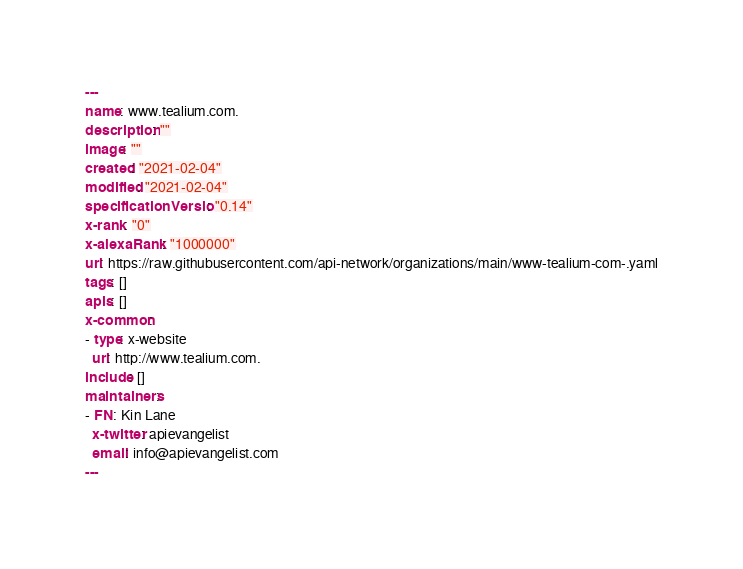Convert code to text. <code><loc_0><loc_0><loc_500><loc_500><_YAML_>---
name: www.tealium.com.
description: ""
image: ""
created: "2021-02-04"
modified: "2021-02-04"
specificationVersion: "0.14"
x-rank: "0"
x-alexaRank: "1000000"
url: https://raw.githubusercontent.com/api-network/organizations/main/www-tealium-com-.yaml
tags: []
apis: []
x-common:
- type: x-website
  url: http://www.tealium.com.
include: []
maintainers:
- FN: Kin Lane
  x-twitter: apievangelist
  email: info@apievangelist.com
---</code> 